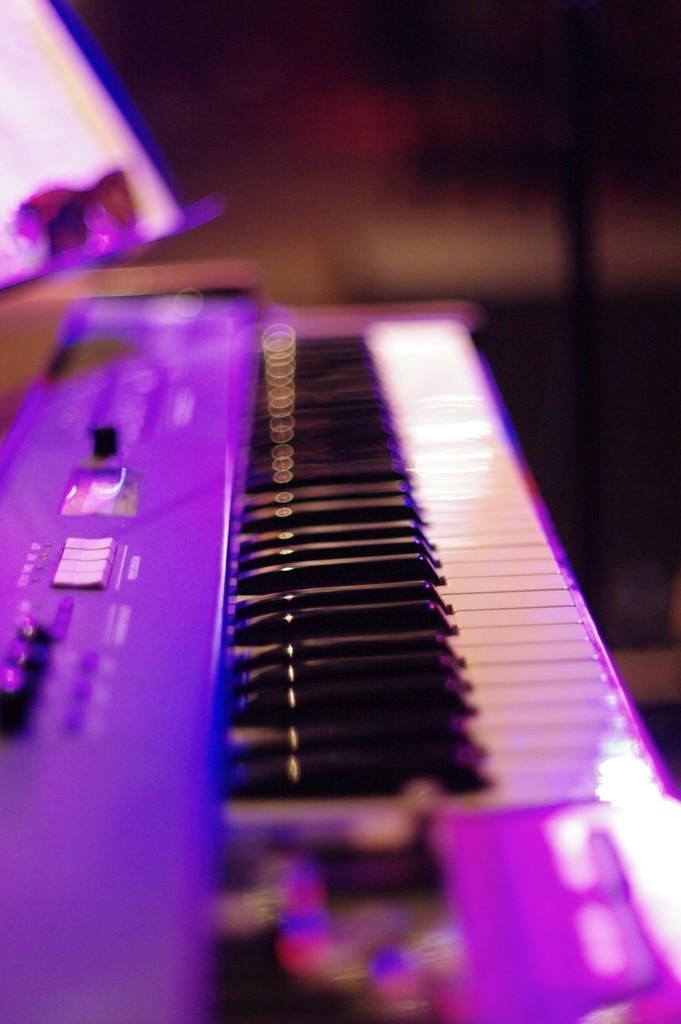Could you give a brief overview of what you see in this image? In this image i can see a piano. 